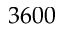Convert formula to latex. <formula><loc_0><loc_0><loc_500><loc_500>3 6 0 0</formula> 